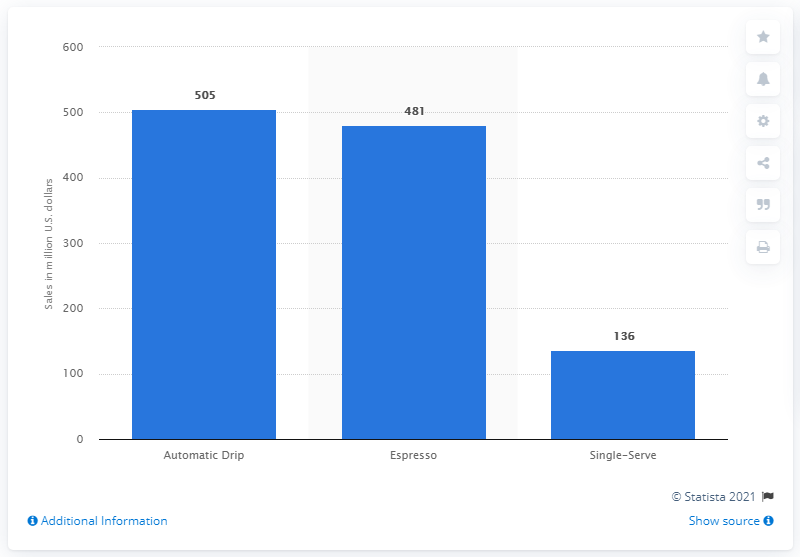Give some essential details in this illustration. The retail sales of espresso machines in the United States in 2010 were 481. 